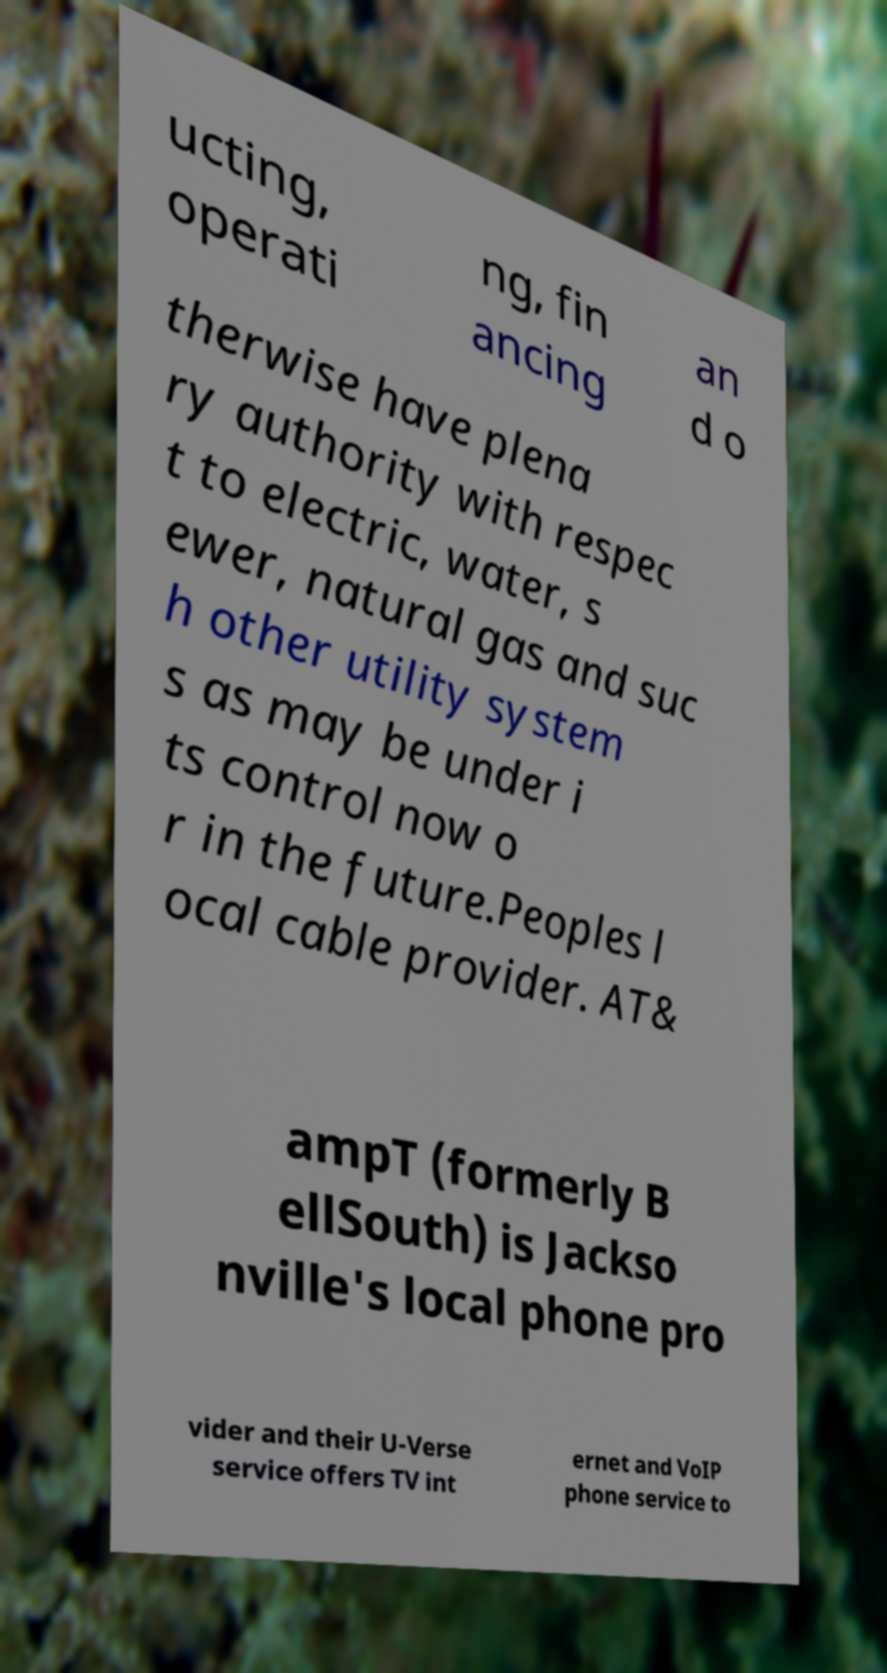For documentation purposes, I need the text within this image transcribed. Could you provide that? ucting, operati ng, fin ancing an d o therwise have plena ry authority with respec t to electric, water, s ewer, natural gas and suc h other utility system s as may be under i ts control now o r in the future.Peoples l ocal cable provider. AT& ampT (formerly B ellSouth) is Jackso nville's local phone pro vider and their U-Verse service offers TV int ernet and VoIP phone service to 